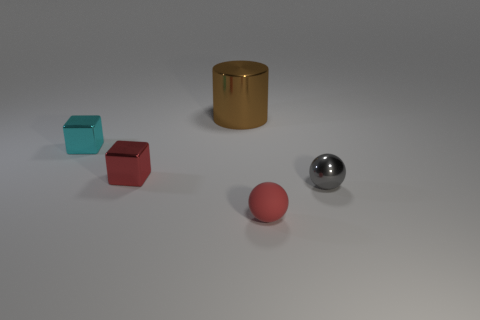Add 1 tiny metallic objects. How many objects exist? 6 Subtract all cubes. How many objects are left? 3 Add 1 metal things. How many metal things exist? 5 Subtract 0 purple cylinders. How many objects are left? 5 Subtract all metallic objects. Subtract all tiny matte things. How many objects are left? 0 Add 1 shiny balls. How many shiny balls are left? 2 